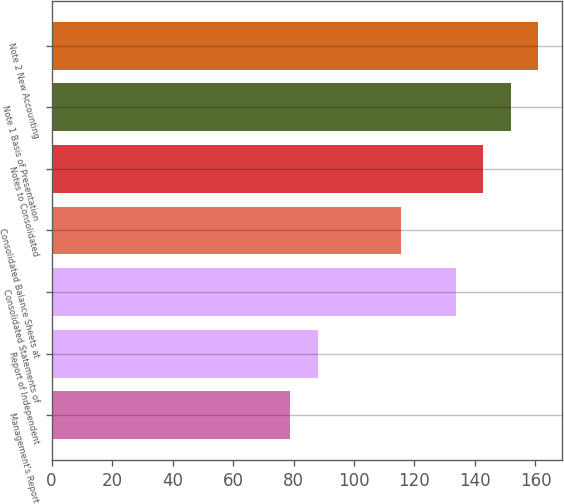Convert chart to OTSL. <chart><loc_0><loc_0><loc_500><loc_500><bar_chart><fcel>Management's Report<fcel>Report of Independent<fcel>Consolidated Statements of<fcel>Consolidated Balance Sheets at<fcel>Notes to Consolidated<fcel>Note 1 Basis of Presentation<fcel>Note 2 New Accounting<nl><fcel>79<fcel>88.1<fcel>133.6<fcel>115.4<fcel>142.7<fcel>151.8<fcel>160.9<nl></chart> 